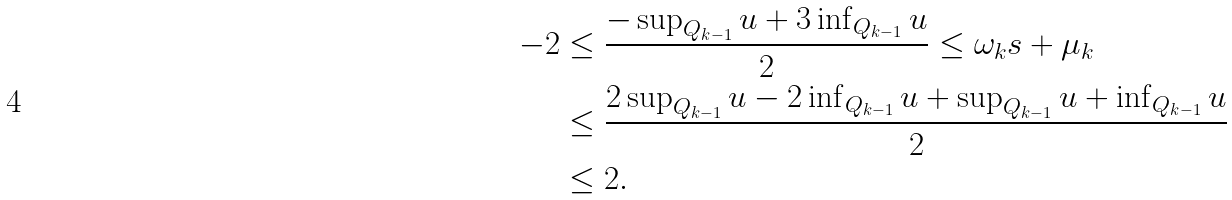Convert formula to latex. <formula><loc_0><loc_0><loc_500><loc_500>- 2 & \leq \frac { - \sup _ { Q _ { k - 1 } } u + 3 \inf _ { Q _ { k - 1 } } u } { 2 } \leq \omega _ { k } s + \mu _ { k } \\ & \leq \frac { 2 \sup _ { Q _ { k - 1 } } u - 2 \inf _ { Q _ { k - 1 } } u + \sup _ { Q _ { k - 1 } } u + \inf _ { Q _ { k - 1 } } u } { 2 } \\ & \leq 2 .</formula> 